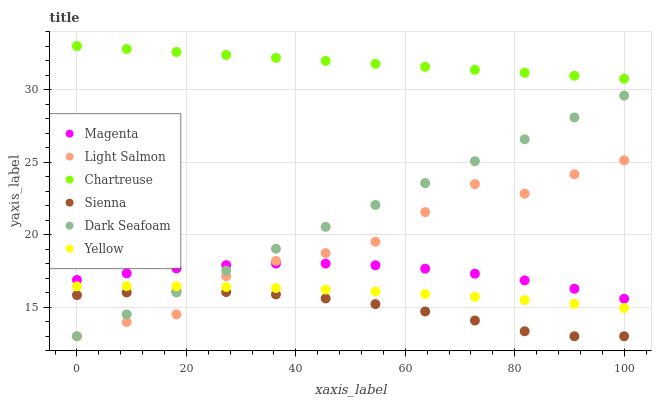Does Sienna have the minimum area under the curve?
Answer yes or no. Yes. Does Chartreuse have the maximum area under the curve?
Answer yes or no. Yes. Does Yellow have the minimum area under the curve?
Answer yes or no. No. Does Yellow have the maximum area under the curve?
Answer yes or no. No. Is Dark Seafoam the smoothest?
Answer yes or no. Yes. Is Light Salmon the roughest?
Answer yes or no. Yes. Is Chartreuse the smoothest?
Answer yes or no. No. Is Chartreuse the roughest?
Answer yes or no. No. Does Light Salmon have the lowest value?
Answer yes or no. Yes. Does Yellow have the lowest value?
Answer yes or no. No. Does Chartreuse have the highest value?
Answer yes or no. Yes. Does Yellow have the highest value?
Answer yes or no. No. Is Yellow less than Magenta?
Answer yes or no. Yes. Is Yellow greater than Sienna?
Answer yes or no. Yes. Does Sienna intersect Dark Seafoam?
Answer yes or no. Yes. Is Sienna less than Dark Seafoam?
Answer yes or no. No. Is Sienna greater than Dark Seafoam?
Answer yes or no. No. Does Yellow intersect Magenta?
Answer yes or no. No. 